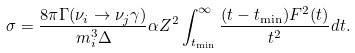Convert formula to latex. <formula><loc_0><loc_0><loc_500><loc_500>\sigma = \frac { 8 \pi \Gamma ( \nu _ { i } \rightarrow \nu _ { j } \gamma ) } { m ^ { 3 } _ { i } \Delta } \alpha Z ^ { 2 } \int ^ { \infty } _ { t _ { \min } } \frac { ( t - t _ { \min } ) F ^ { 2 } ( t ) } { t ^ { 2 } } d t .</formula> 